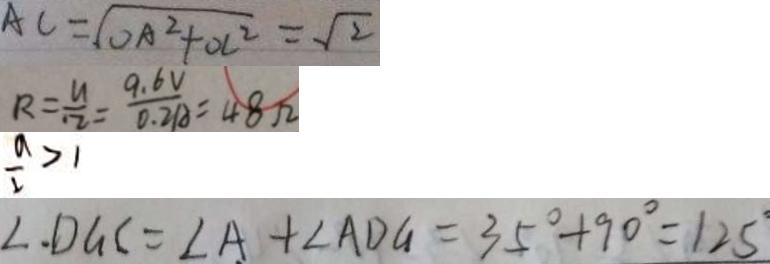<formula> <loc_0><loc_0><loc_500><loc_500>A C = \sqrt { O A ^ { 2 } + O C ^ { 2 } } = \sqrt { 2 } 
 R = \frac { u } { 1 2 } = \frac { 9 . 6 V } { 0 . 2 A } = 4 8 \Omega 
 \frac { a } { 2 } > 1 
 \angle . D G C = \angle A + \angle A D G = 3 5 ^ { \circ } + 9 0 ^ { \circ } = 1 2 5</formula> 